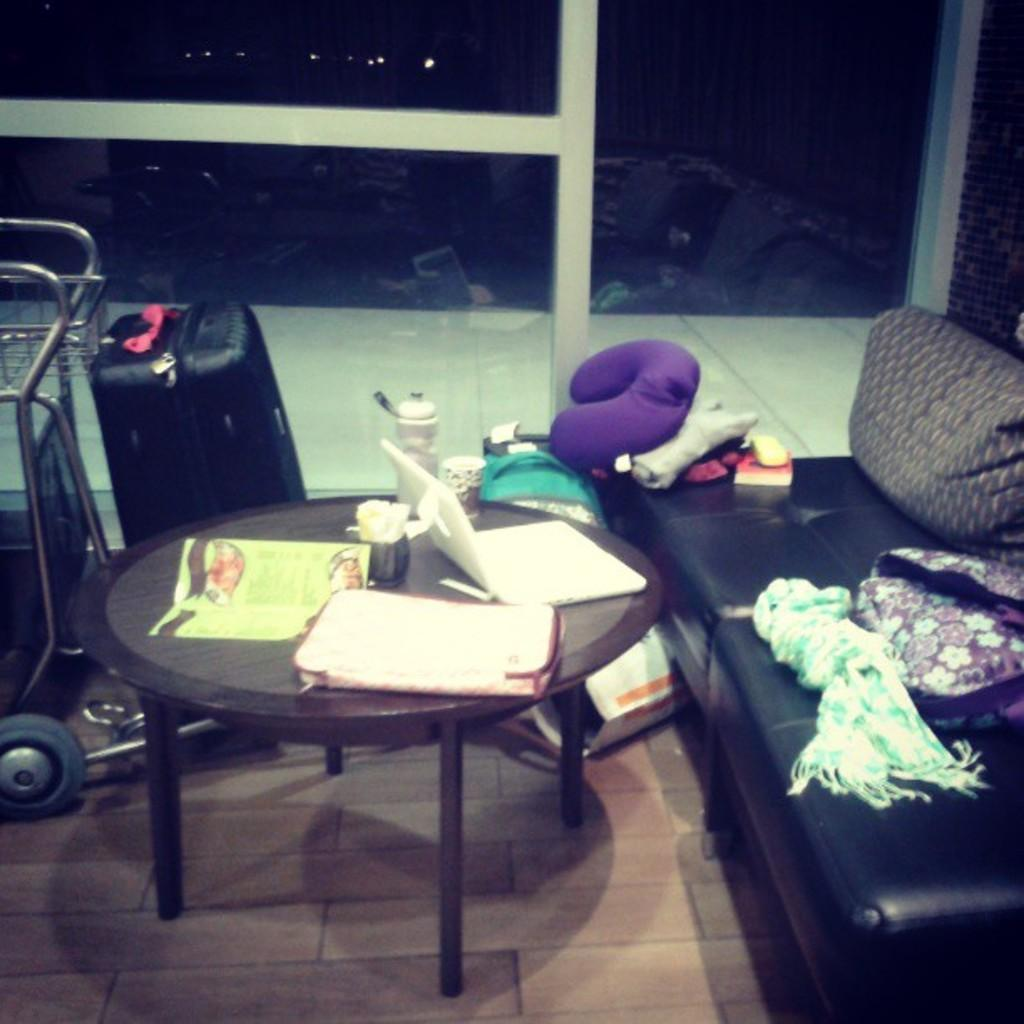What electronic device is visible in the image? There is a laptop in the image. What type of container is present in the image? There is a bowl in the image. What can be found on the table in the image? There are objects on the table. What type of bag is in the image? There is a luggage bag in the image. What type of transportation device is in the image? There is a trolley in the image. What type of furniture is in the image? There is a sofa in the image. What type of material is in the image? There is cloth in the image. What other objects can be seen in the image? There are other objects in the image. What can be seen in the background of the image? There is a light in the background of the image. How many goldfish are swimming in the bowl in the image? There are no goldfish present in the image; it only contains a bowl. What type of pancake is being served on the trolley in the image? There is no pancake present in the image; the trolley is not serving food. 